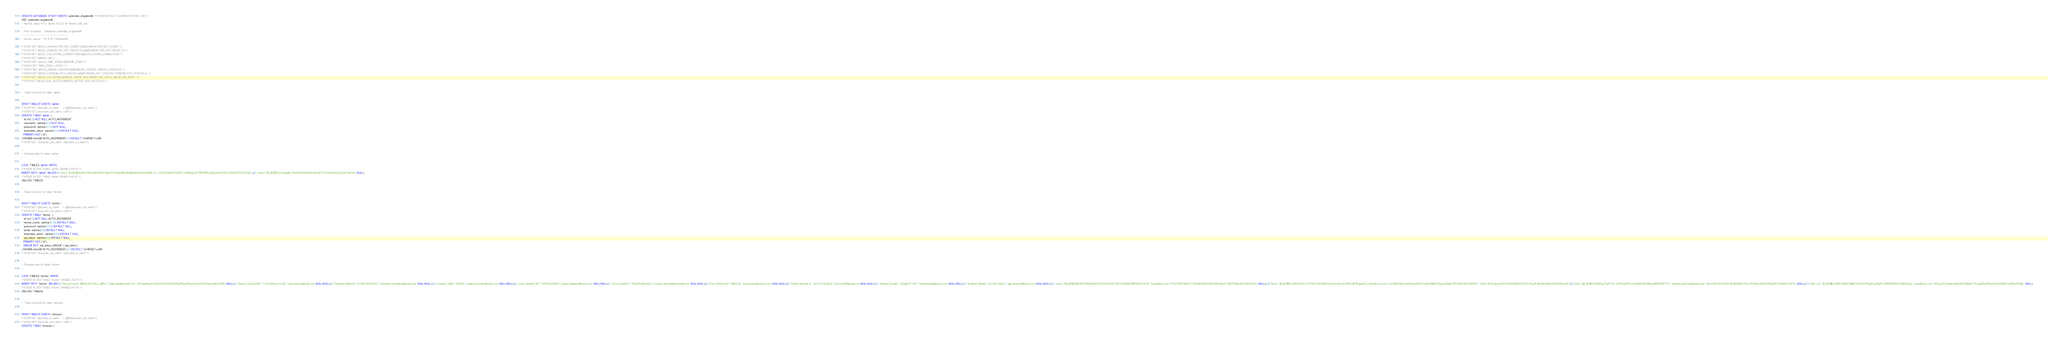Convert code to text. <code><loc_0><loc_0><loc_500><loc_500><_SQL_>CREATE DATABASE  IF NOT EXISTS `automatic_irrigationdb` /*!40100 DEFAULT CHARACTER SET utf8 */;
USE `automatic_irrigationdb`;
-- MySQL dump 10.13  Distrib 5.6.23, for Win64 (x86_64)
--
-- Host: localhost    Database: automatic_irrigationdb
-- ------------------------------------------------------
-- Server version	5.5.5-10.1.13-MariaDB

/*!40101 SET @OLD_CHARACTER_SET_CLIENT=@@CHARACTER_SET_CLIENT */;
/*!40101 SET @OLD_CHARACTER_SET_RESULTS=@@CHARACTER_SET_RESULTS */;
/*!40101 SET @OLD_COLLATION_CONNECTION=@@COLLATION_CONNECTION */;
/*!40101 SET NAMES utf8 */;
/*!40103 SET @OLD_TIME_ZONE=@@TIME_ZONE */;
/*!40103 SET TIME_ZONE='+00:00' */;
/*!40014 SET @OLD_UNIQUE_CHECKS=@@UNIQUE_CHECKS, UNIQUE_CHECKS=0 */;
/*!40014 SET @OLD_FOREIGN_KEY_CHECKS=@@FOREIGN_KEY_CHECKS, FOREIGN_KEY_CHECKS=0 */;
/*!40101 SET @OLD_SQL_MODE=@@SQL_MODE, SQL_MODE='NO_AUTO_VALUE_ON_ZERO' */;
/*!40111 SET @OLD_SQL_NOTES=@@SQL_NOTES, SQL_NOTES=0 */;

--
-- Table structure for table `admin`
--

DROP TABLE IF EXISTS `admin`;
/*!40101 SET @saved_cs_client     = @@character_set_client */;
/*!40101 SET character_set_client = utf8 */;
CREATE TABLE `admin` (
  `id` int(11) NOT NULL AUTO_INCREMENT,
  `username` varchar(45) NOT NULL,
  `password` varchar(255) NOT NULL,
  `remember_token` varchar(100) DEFAULT NULL,
  PRIMARY KEY (`id`)
) ENGINE=InnoDB AUTO_INCREMENT=3 DEFAULT CHARSET=utf8;
/*!40101 SET character_set_client = @saved_cs_client */;

--
-- Dumping data for table `admin`
--

LOCK TABLES `admin` WRITE;
/*!40000 ALTER TABLE `admin` DISABLE KEYS */;
INSERT INTO `admin` VALUES (1,'nana','$2y$11$jXn8VtQ1Os2qFhlG9nTakeATzSvleeRMdWaBqHnrIV4dswDENEc.6','x8z7kUahKCP836VLYJBuRgL0k75BFPBRzZEBj4eoZ95ACcZ8nCEP95QV2zIU'),(2,'nana1','$2y$11$Z6CuOpdgNcT8wQ0hX69deu0ch6/GCV7/ziXoyNe5JZoi/xkYWo9cu',NULL);
/*!40000 ALTER TABLE `admin` ENABLE KEYS */;
UNLOCK TABLES;

--
-- Table structure for table `farmer`
--

DROP TABLE IF EXISTS `farmer`;
/*!40101 SET @saved_cs_client     = @@character_set_client */;
/*!40101 SET character_set_client = utf8 */;
CREATE TABLE `farmer` (
  `id` int(11) NOT NULL AUTO_INCREMENT,
  `farmer_name` varchar(256) DEFAULT NULL,
  `password` varchar(256) DEFAULT NULL,
  `email` varchar(60) DEFAULT NULL,
  `remember_token` varchar(100) DEFAULT NULL,
  `api_token` varchar(60) DEFAULT NULL,
  PRIMARY KEY (`id`),
  UNIQUE KEY `api_token_UNIQUE` (`api_token`)
) ENGINE=InnoDB AUTO_INCREMENT=21 DEFAULT CHARSET=utf8;
/*!40101 SET character_set_client = @saved_cs_client */;

--
-- Dumping data for table `farmer`
--

LOCK TABLES `farmer` WRITE;
/*!40000 ALTER TABLE `farmer` DISABLE KEYS */;
INSERT INTO `farmer` VALUES (2,'Rhoda Farrell','$Mc8oXA~eKjv_d|]PUr','fadel.zula@schultz.info','w91nqdhqzXUvpGt5v2d3tVaSZ6NjjlXXijuGVhaQOswK3vu2wruyHleXxUEB',NULL),(3,'Gerson Carroll DDS','%`Ex=M*uks<\\>L|K','runte.waino@gmail.com',NULL,NULL),(4,'Freeman Balistreri','#.Oz8o=A29>}4Q','eichmann.marcelina@gmail.com',NULL,NULL),(5,'Lisandro Leffler',']4|Q`lD','caroline.kautzer@metz.com',NULL,NULL),(6,'Lonzo Goldner MD','\\4262wZmll?b','pagac.madisen@hane.com',NULL,NULL),(7,'Vince Graham','Y&uLN0yf|wJit:Eu','corkery.darren@vonrueden.net',NULL,NULL),(8,'Ross Rutherford','ANmf+j6','hane.dasia@yahoo.com',NULL,NULL),(9,'Sheila Gerhold Jr.','&o3_HTdy5])]r2','brycen19@gmail.com',NULL,NULL),(10,'Adriana Kuvalis','J[GqpUf?`~LB~','kbalistreri@gleason.com',NULL,NULL),(11,'Esteban Mueller','Ao%{V;nJb|v)>','gpowlowski@hand.com',NULL,NULL),(16,'mens','$2y$11$jGD83FIFfJEDbidKdG3TkO0ciOntX76UTUp9l1dnZBRQfbFt5xH12','nana@set.com','lfTjOFt9SObu9vrTGPdHpHfgRmW2irD0tn16qxF7tShPOfbp4FHolX61cZZA',NULL),(18,'Nana','$2y$11$Se.1DKXN1C2x377Wy.Fp6O/iph60.4poH.iFeLxksXOFqW3DqpdmG','blue@com.com','IxLABsh5bwFmsIfVponK6ytZxsAbGNMuGt5gsySlmgCQFFu5pUhIhZo4ED4X','1aSnx1AQyOjcprUoFS4cIAGpfEESSv7DLrQeytFHboIferN4MoX2pAGKne09'),(19,'kelo','$2y$11$mZKqEQg7GyRrY8..x63FjegSfPLtVxkrkMuv8f3zNpe1WHDKWTYx.','kelvinasare5.ka@gmail.com','McxU893VufUVEDc1la3NStpIn0YaLcI7PeIenU4nEW3O0gWY2Xu4l4ToaRTe',NULL),(20,'Men Joe','$2y$11$KuXiBhYHulhZQgM2VcnhFOPAqyRnjZQqPt.XtfBK8HSDLGcMDQu6q','mjoe@xyz.com','KDzjonZVLp8skxnBUmi0GW8qnY7kuugERpSRdy6sI2m46bMYor9HdcR0qbIL',NULL);
/*!40000 ALTER TABLE `farmer` ENABLE KEYS */;
UNLOCK TABLES;

--
-- Table structure for table `intrusion`
--

DROP TABLE IF EXISTS `intrusion`;
/*!40101 SET @saved_cs_client     = @@character_set_client */;
/*!40101 SET character_set_client = utf8 */;
CREATE TABLE `intrusion` (</code> 